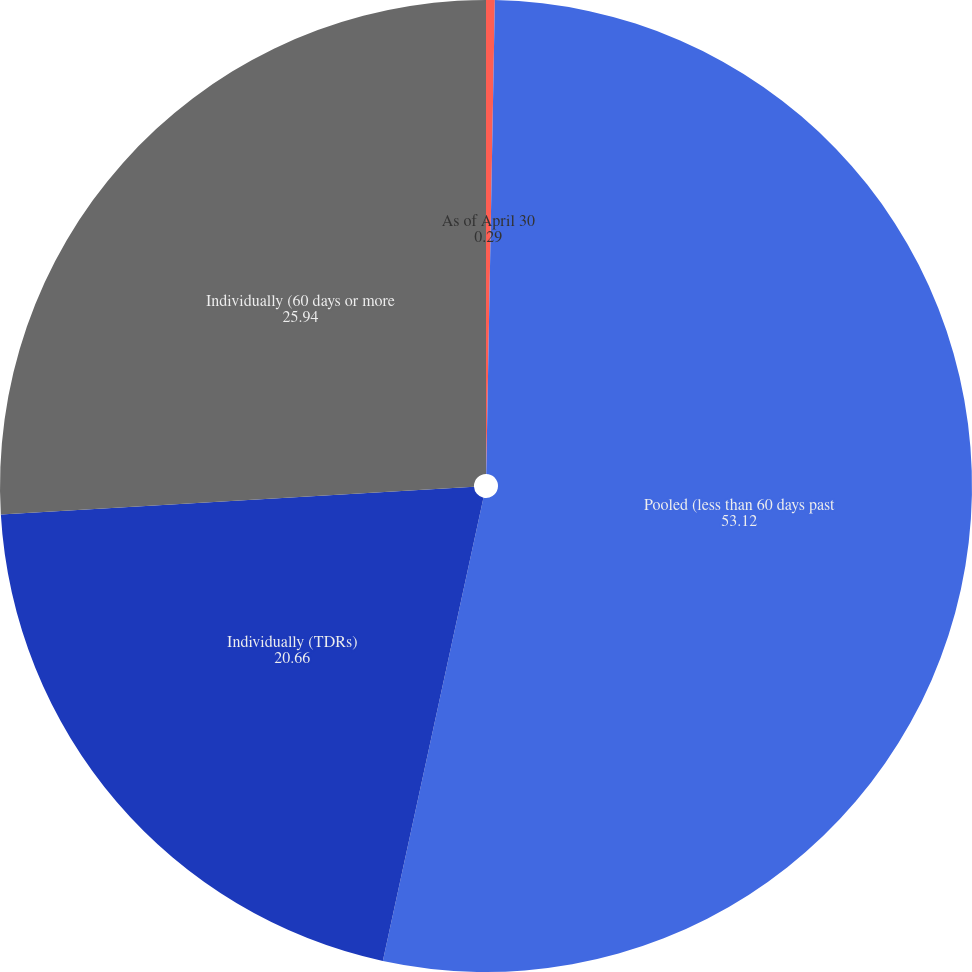Convert chart to OTSL. <chart><loc_0><loc_0><loc_500><loc_500><pie_chart><fcel>As of April 30<fcel>Pooled (less than 60 days past<fcel>Individually (TDRs)<fcel>Individually (60 days or more<nl><fcel>0.29%<fcel>53.12%<fcel>20.66%<fcel>25.94%<nl></chart> 